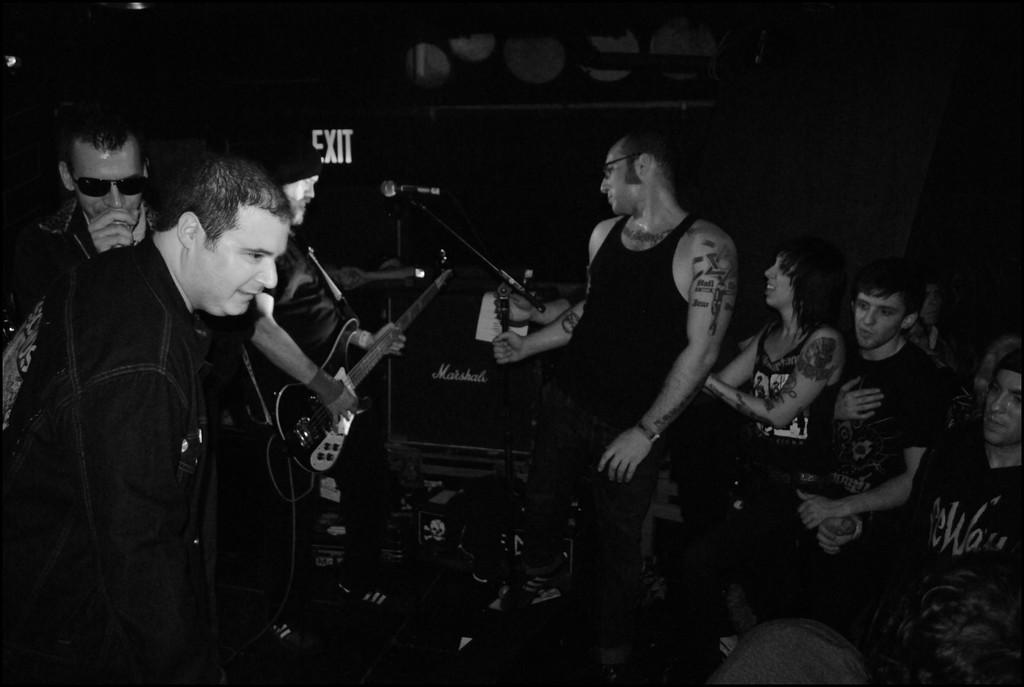How many people are in the image? There are people in the image, but the exact number is not specified. What are the majority of people doing in the image? Most of the people are standing. Are there any people sitting in the image? Yes, some people are sitting. What is the man holding in the image? The man is holding a guitar. Where is the man positioned in relation to the microphone? The man is in front of a microphone. What type of snake is wrapped around the microphone in the image? There is no snake present in the image; it features people, a guitar, and a microphone. What kind of operation is being performed on the man holding the guitar in the image? There is no operation being performed on the man holding the guitar in the image. 